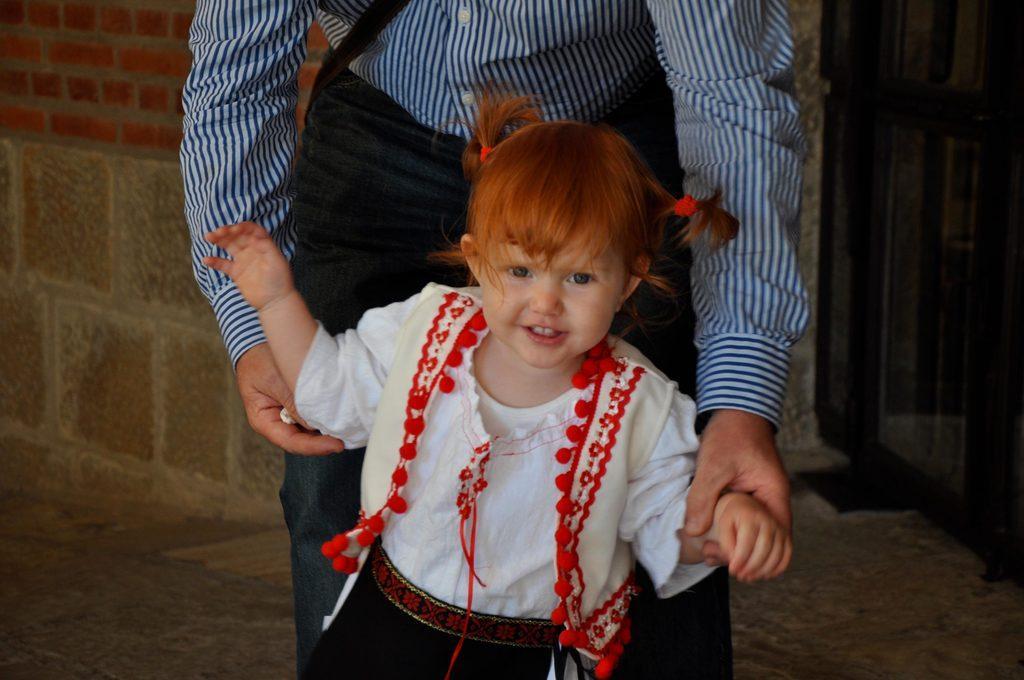Could you give a brief overview of what you see in this image? In this image we can see group of persons standing on the ground. One kid is wearing a white dress and in the background we can see a door. 